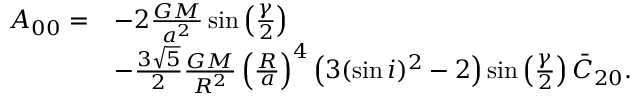<formula> <loc_0><loc_0><loc_500><loc_500>\begin{array} { r l } { A _ { 0 0 } = } & { - 2 \frac { G M } { a ^ { 2 } } \sin \left ( \frac { \gamma } { 2 } \right ) } \\ & { - \frac { 3 \sqrt { 5 } } { 2 } \frac { G M } { R ^ { 2 } } \left ( \frac { R } { a } \right ) ^ { 4 } \left ( 3 ( \sin i ) ^ { 2 } - 2 \right ) \sin \left ( \frac { \gamma } { 2 } \right ) \bar { C } _ { 2 0 } . } \end{array}</formula> 